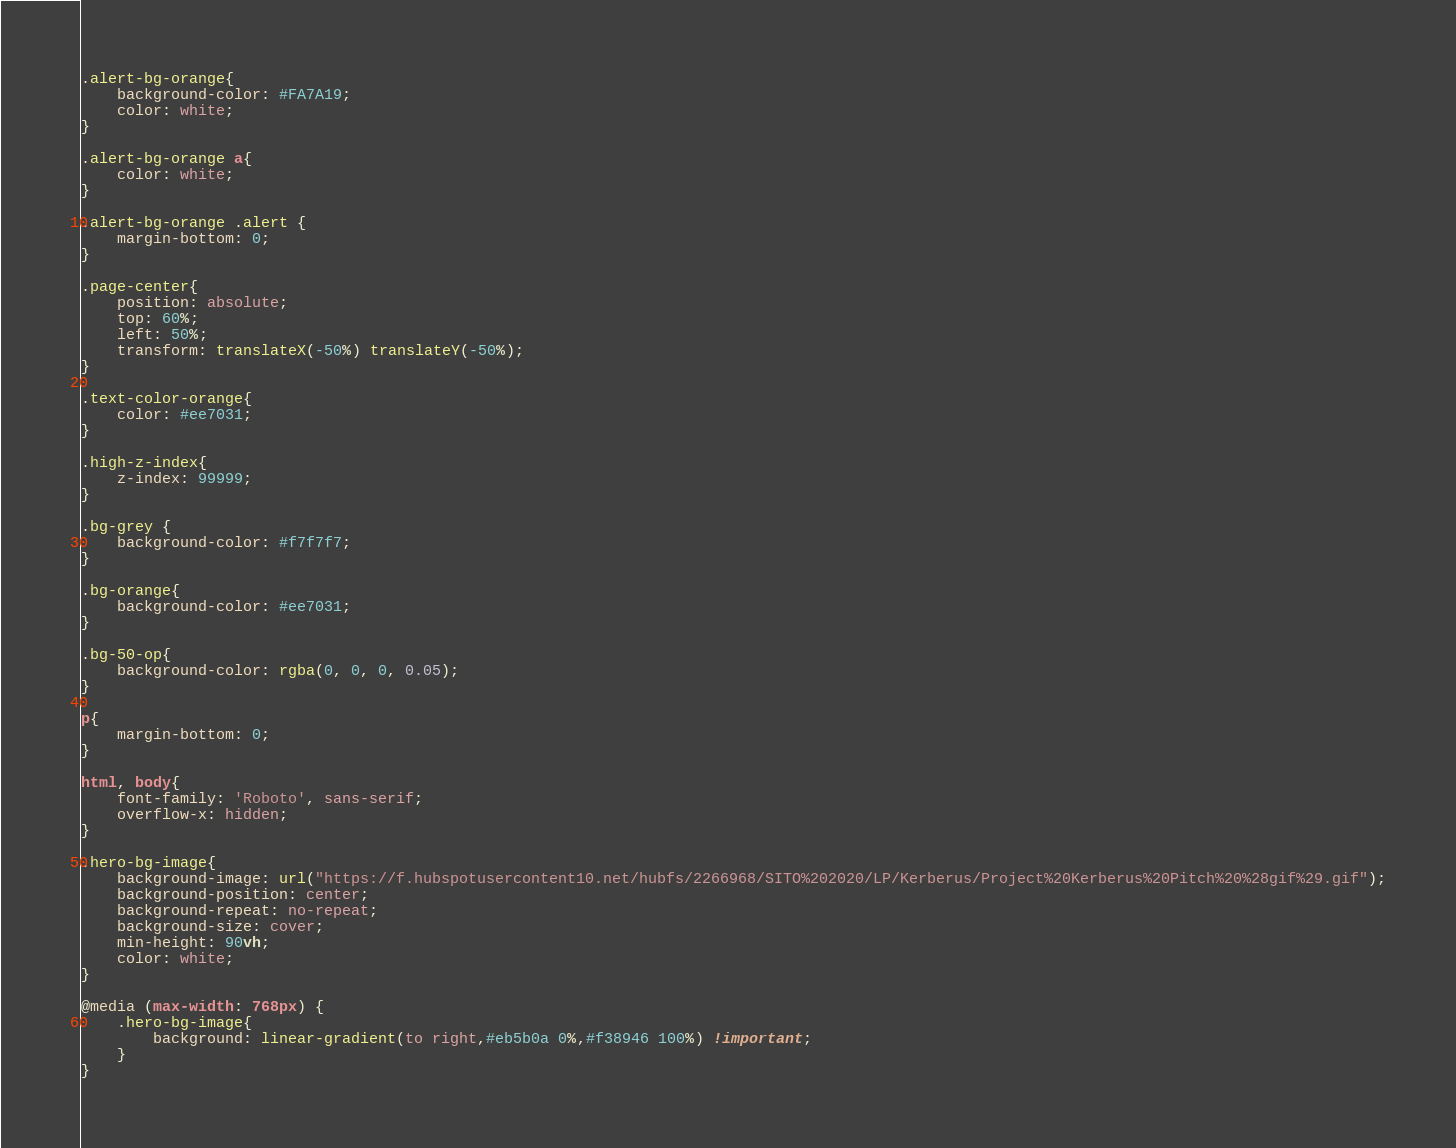Convert code to text. <code><loc_0><loc_0><loc_500><loc_500><_CSS_>.alert-bg-orange{
    background-color: #FA7A19;
    color: white;
}

.alert-bg-orange a{ 
    color: white;
}

.alert-bg-orange .alert {
    margin-bottom: 0;
}

.page-center{
    position: absolute;
    top: 60%;
    left: 50%;
    transform: translateX(-50%) translateY(-50%);
}

.text-color-orange{
    color: #ee7031;
}

.high-z-index{
    z-index: 99999;
}

.bg-grey {
    background-color: #f7f7f7;
}

.bg-orange{
    background-color: #ee7031;
}

.bg-50-op{
    background-color: rgba(0, 0, 0, 0.05);
}

p{
    margin-bottom: 0;
}

html, body{
    font-family: 'Roboto', sans-serif;
    overflow-x: hidden;
}

.hero-bg-image{
    background-image: url("https://f.hubspotusercontent10.net/hubfs/2266968/SITO%202020/LP/Kerberus/Project%20Kerberus%20Pitch%20%28gif%29.gif");
    background-position: center;
    background-repeat: no-repeat;
    background-size: cover;
    min-height: 90vh;
    color: white;
}

@media (max-width: 768px) { 
    .hero-bg-image{
        background: linear-gradient(to right,#eb5b0a 0%,#f38946 100%) !important;
    }
}</code> 